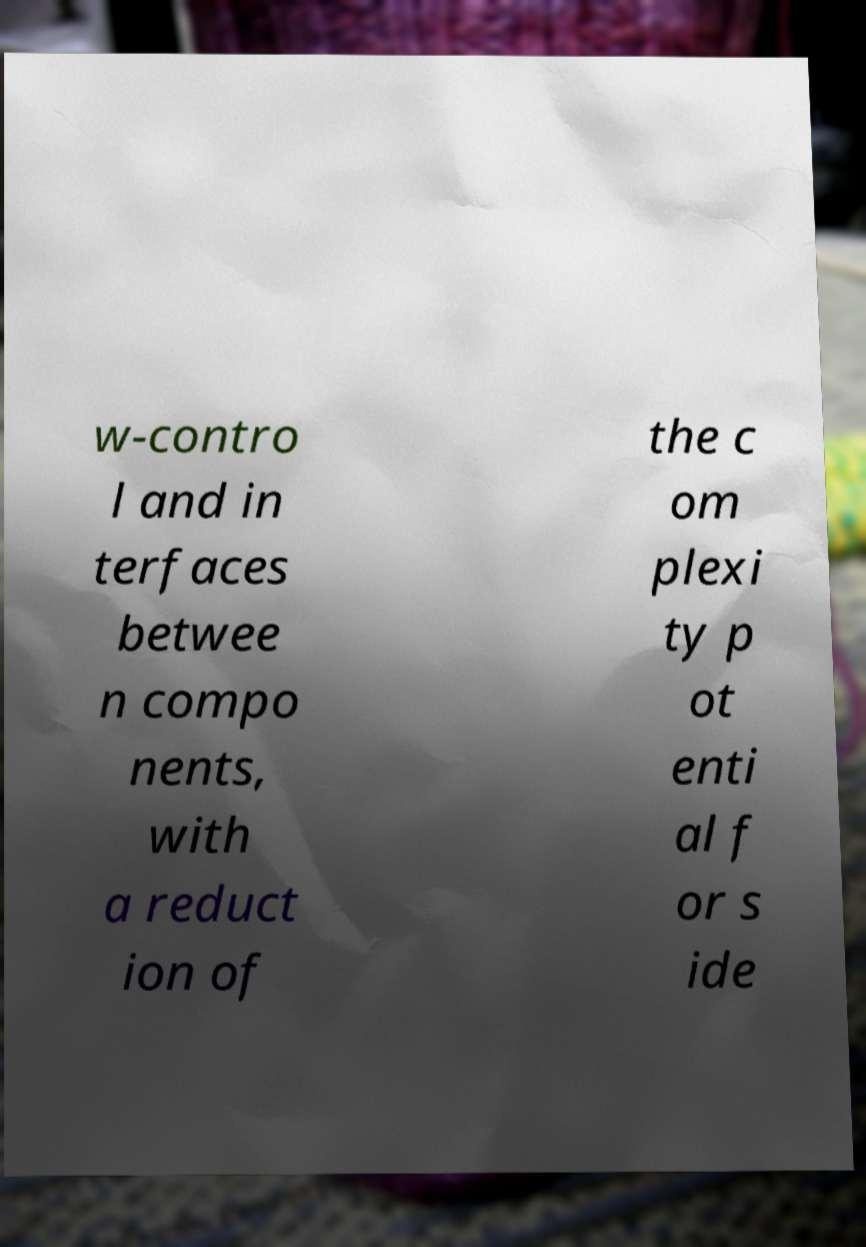There's text embedded in this image that I need extracted. Can you transcribe it verbatim? w-contro l and in terfaces betwee n compo nents, with a reduct ion of the c om plexi ty p ot enti al f or s ide 